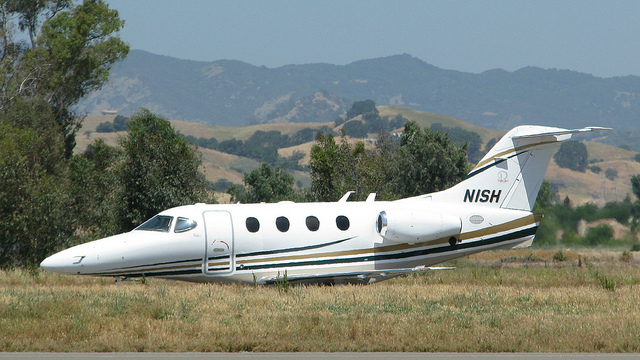Please extract the text content from this image. NISH 